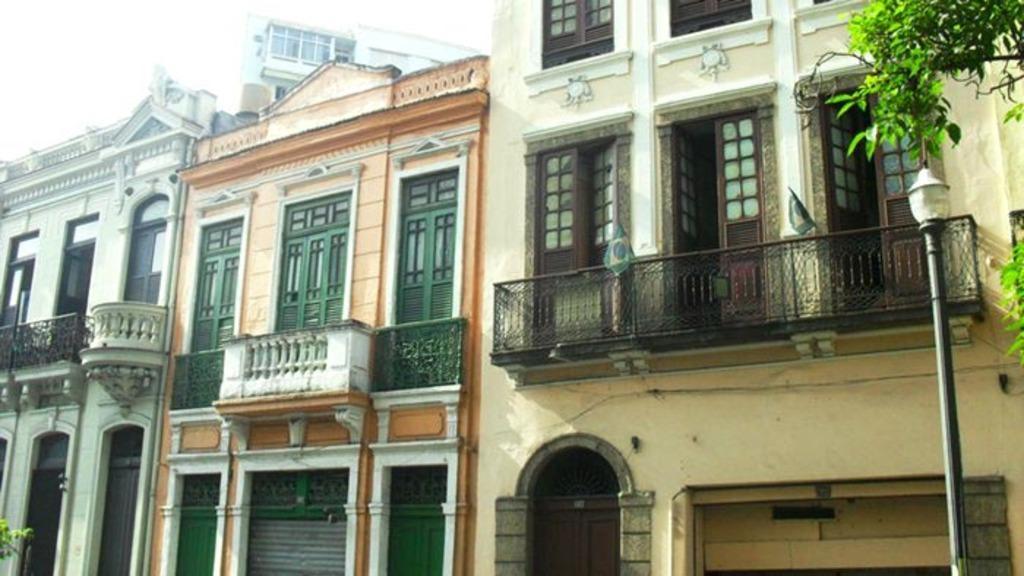In one or two sentences, can you explain what this image depicts? In this image there are buildings having balconies. Right side there is a street light. Right top there are trees. Left top there is sky. 